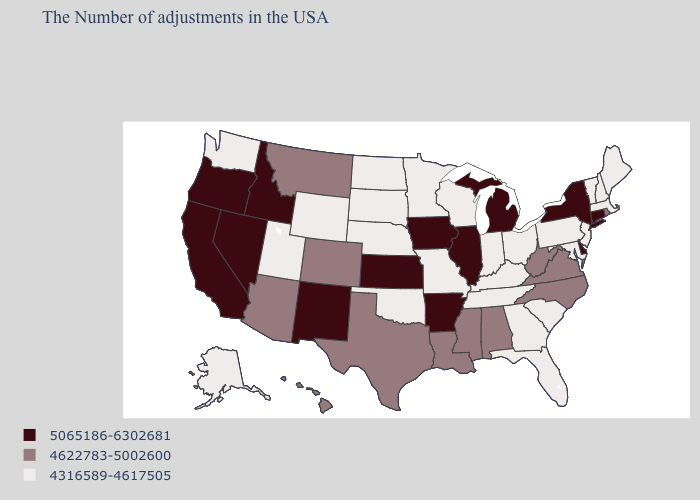Which states have the lowest value in the West?
Be succinct. Wyoming, Utah, Washington, Alaska. What is the highest value in the West ?
Quick response, please. 5065186-6302681. Which states have the lowest value in the USA?
Answer briefly. Maine, Massachusetts, New Hampshire, Vermont, New Jersey, Maryland, Pennsylvania, South Carolina, Ohio, Florida, Georgia, Kentucky, Indiana, Tennessee, Wisconsin, Missouri, Minnesota, Nebraska, Oklahoma, South Dakota, North Dakota, Wyoming, Utah, Washington, Alaska. Which states have the lowest value in the USA?
Give a very brief answer. Maine, Massachusetts, New Hampshire, Vermont, New Jersey, Maryland, Pennsylvania, South Carolina, Ohio, Florida, Georgia, Kentucky, Indiana, Tennessee, Wisconsin, Missouri, Minnesota, Nebraska, Oklahoma, South Dakota, North Dakota, Wyoming, Utah, Washington, Alaska. Which states have the lowest value in the West?
Concise answer only. Wyoming, Utah, Washington, Alaska. Does Ohio have the lowest value in the USA?
Keep it brief. Yes. Name the states that have a value in the range 4622783-5002600?
Answer briefly. Rhode Island, Virginia, North Carolina, West Virginia, Alabama, Mississippi, Louisiana, Texas, Colorado, Montana, Arizona, Hawaii. Does the first symbol in the legend represent the smallest category?
Be succinct. No. Which states hav the highest value in the Northeast?
Be succinct. Connecticut, New York. Which states have the lowest value in the USA?
Answer briefly. Maine, Massachusetts, New Hampshire, Vermont, New Jersey, Maryland, Pennsylvania, South Carolina, Ohio, Florida, Georgia, Kentucky, Indiana, Tennessee, Wisconsin, Missouri, Minnesota, Nebraska, Oklahoma, South Dakota, North Dakota, Wyoming, Utah, Washington, Alaska. Does Nevada have a higher value than New York?
Concise answer only. No. Does Nebraska have the highest value in the USA?
Keep it brief. No. What is the value of Louisiana?
Be succinct. 4622783-5002600. Does Kentucky have the highest value in the USA?
Quick response, please. No. Name the states that have a value in the range 4622783-5002600?
Be succinct. Rhode Island, Virginia, North Carolina, West Virginia, Alabama, Mississippi, Louisiana, Texas, Colorado, Montana, Arizona, Hawaii. 